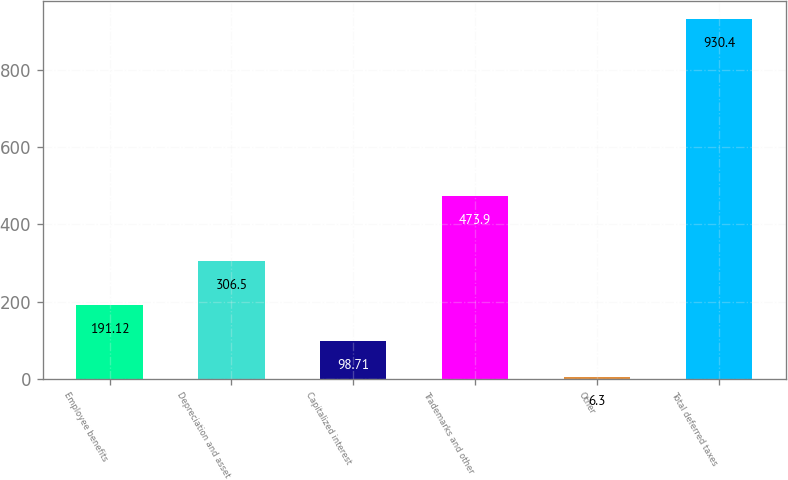Convert chart. <chart><loc_0><loc_0><loc_500><loc_500><bar_chart><fcel>Employee benefits<fcel>Depreciation and asset<fcel>Capitalized interest<fcel>Trademarks and other<fcel>Other<fcel>Total deferred taxes<nl><fcel>191.12<fcel>306.5<fcel>98.71<fcel>473.9<fcel>6.3<fcel>930.4<nl></chart> 